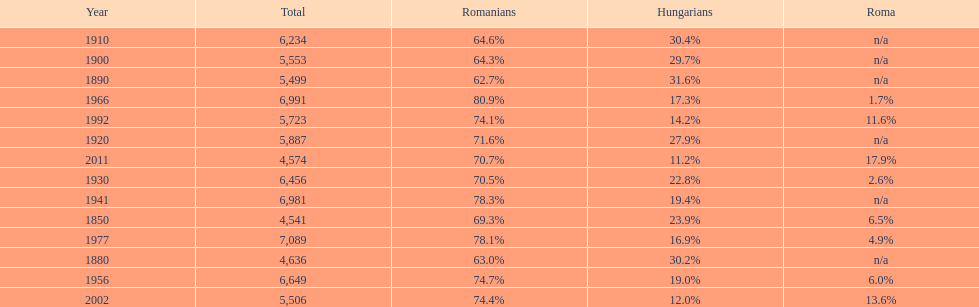What year had the next highest percentage for roma after 2011? 2002. 